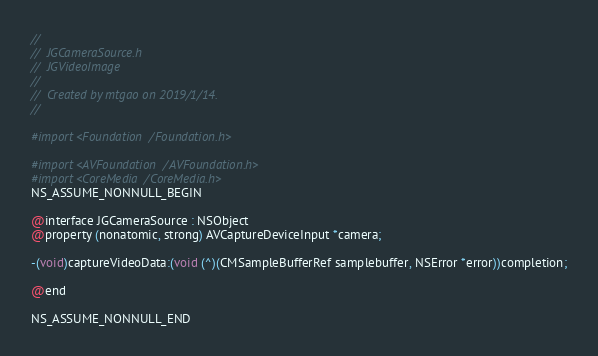<code> <loc_0><loc_0><loc_500><loc_500><_C_>//
//  JGCameraSource.h
//  JGVideoImage
//
//  Created by mtgao on 2019/1/14.
//

#import <Foundation/Foundation.h>

#import <AVFoundation/AVFoundation.h>
#import <CoreMedia/CoreMedia.h>
NS_ASSUME_NONNULL_BEGIN

@interface JGCameraSource : NSObject
@property (nonatomic, strong) AVCaptureDeviceInput *camera;

-(void)captureVideoData:(void (^)(CMSampleBufferRef samplebuffer, NSError *error))completion;

@end

NS_ASSUME_NONNULL_END
</code> 